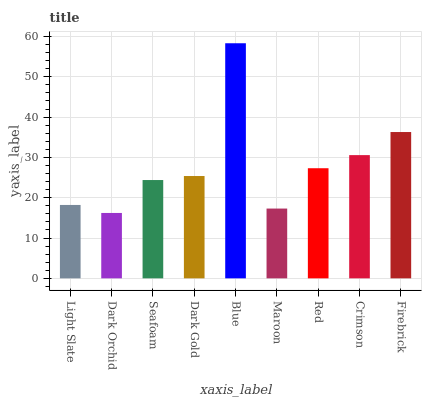Is Dark Orchid the minimum?
Answer yes or no. Yes. Is Blue the maximum?
Answer yes or no. Yes. Is Seafoam the minimum?
Answer yes or no. No. Is Seafoam the maximum?
Answer yes or no. No. Is Seafoam greater than Dark Orchid?
Answer yes or no. Yes. Is Dark Orchid less than Seafoam?
Answer yes or no. Yes. Is Dark Orchid greater than Seafoam?
Answer yes or no. No. Is Seafoam less than Dark Orchid?
Answer yes or no. No. Is Dark Gold the high median?
Answer yes or no. Yes. Is Dark Gold the low median?
Answer yes or no. Yes. Is Crimson the high median?
Answer yes or no. No. Is Dark Orchid the low median?
Answer yes or no. No. 